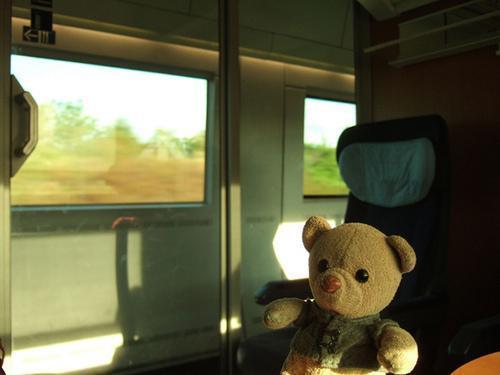How many windows are there?
Give a very brief answer. 2. 